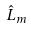Convert formula to latex. <formula><loc_0><loc_0><loc_500><loc_500>\hat { L } _ { m }</formula> 